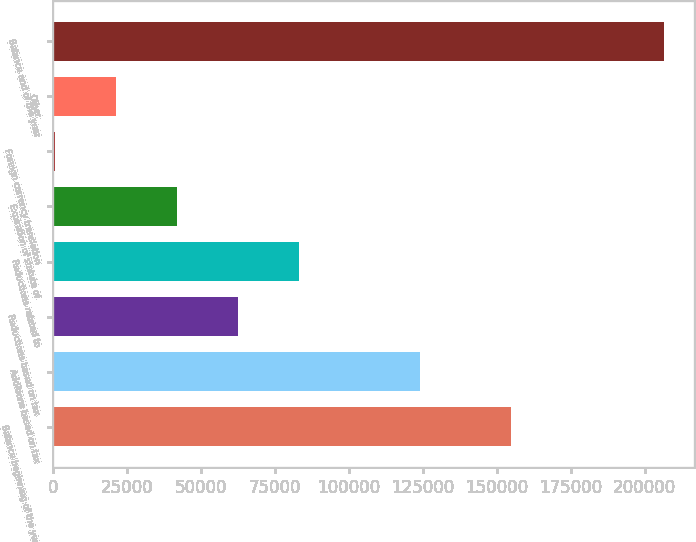Convert chart to OTSL. <chart><loc_0><loc_0><loc_500><loc_500><bar_chart><fcel>Balance beginning of the year<fcel>Additions based on tax<fcel>Reductions based on tax<fcel>Reductions related to<fcel>Expiration of statute of<fcel>Foreign currency translation<fcel>Other<fcel>Balance end of the year<nl><fcel>154848<fcel>124171<fcel>62504.5<fcel>83060<fcel>41949<fcel>838<fcel>21393.5<fcel>206393<nl></chart> 